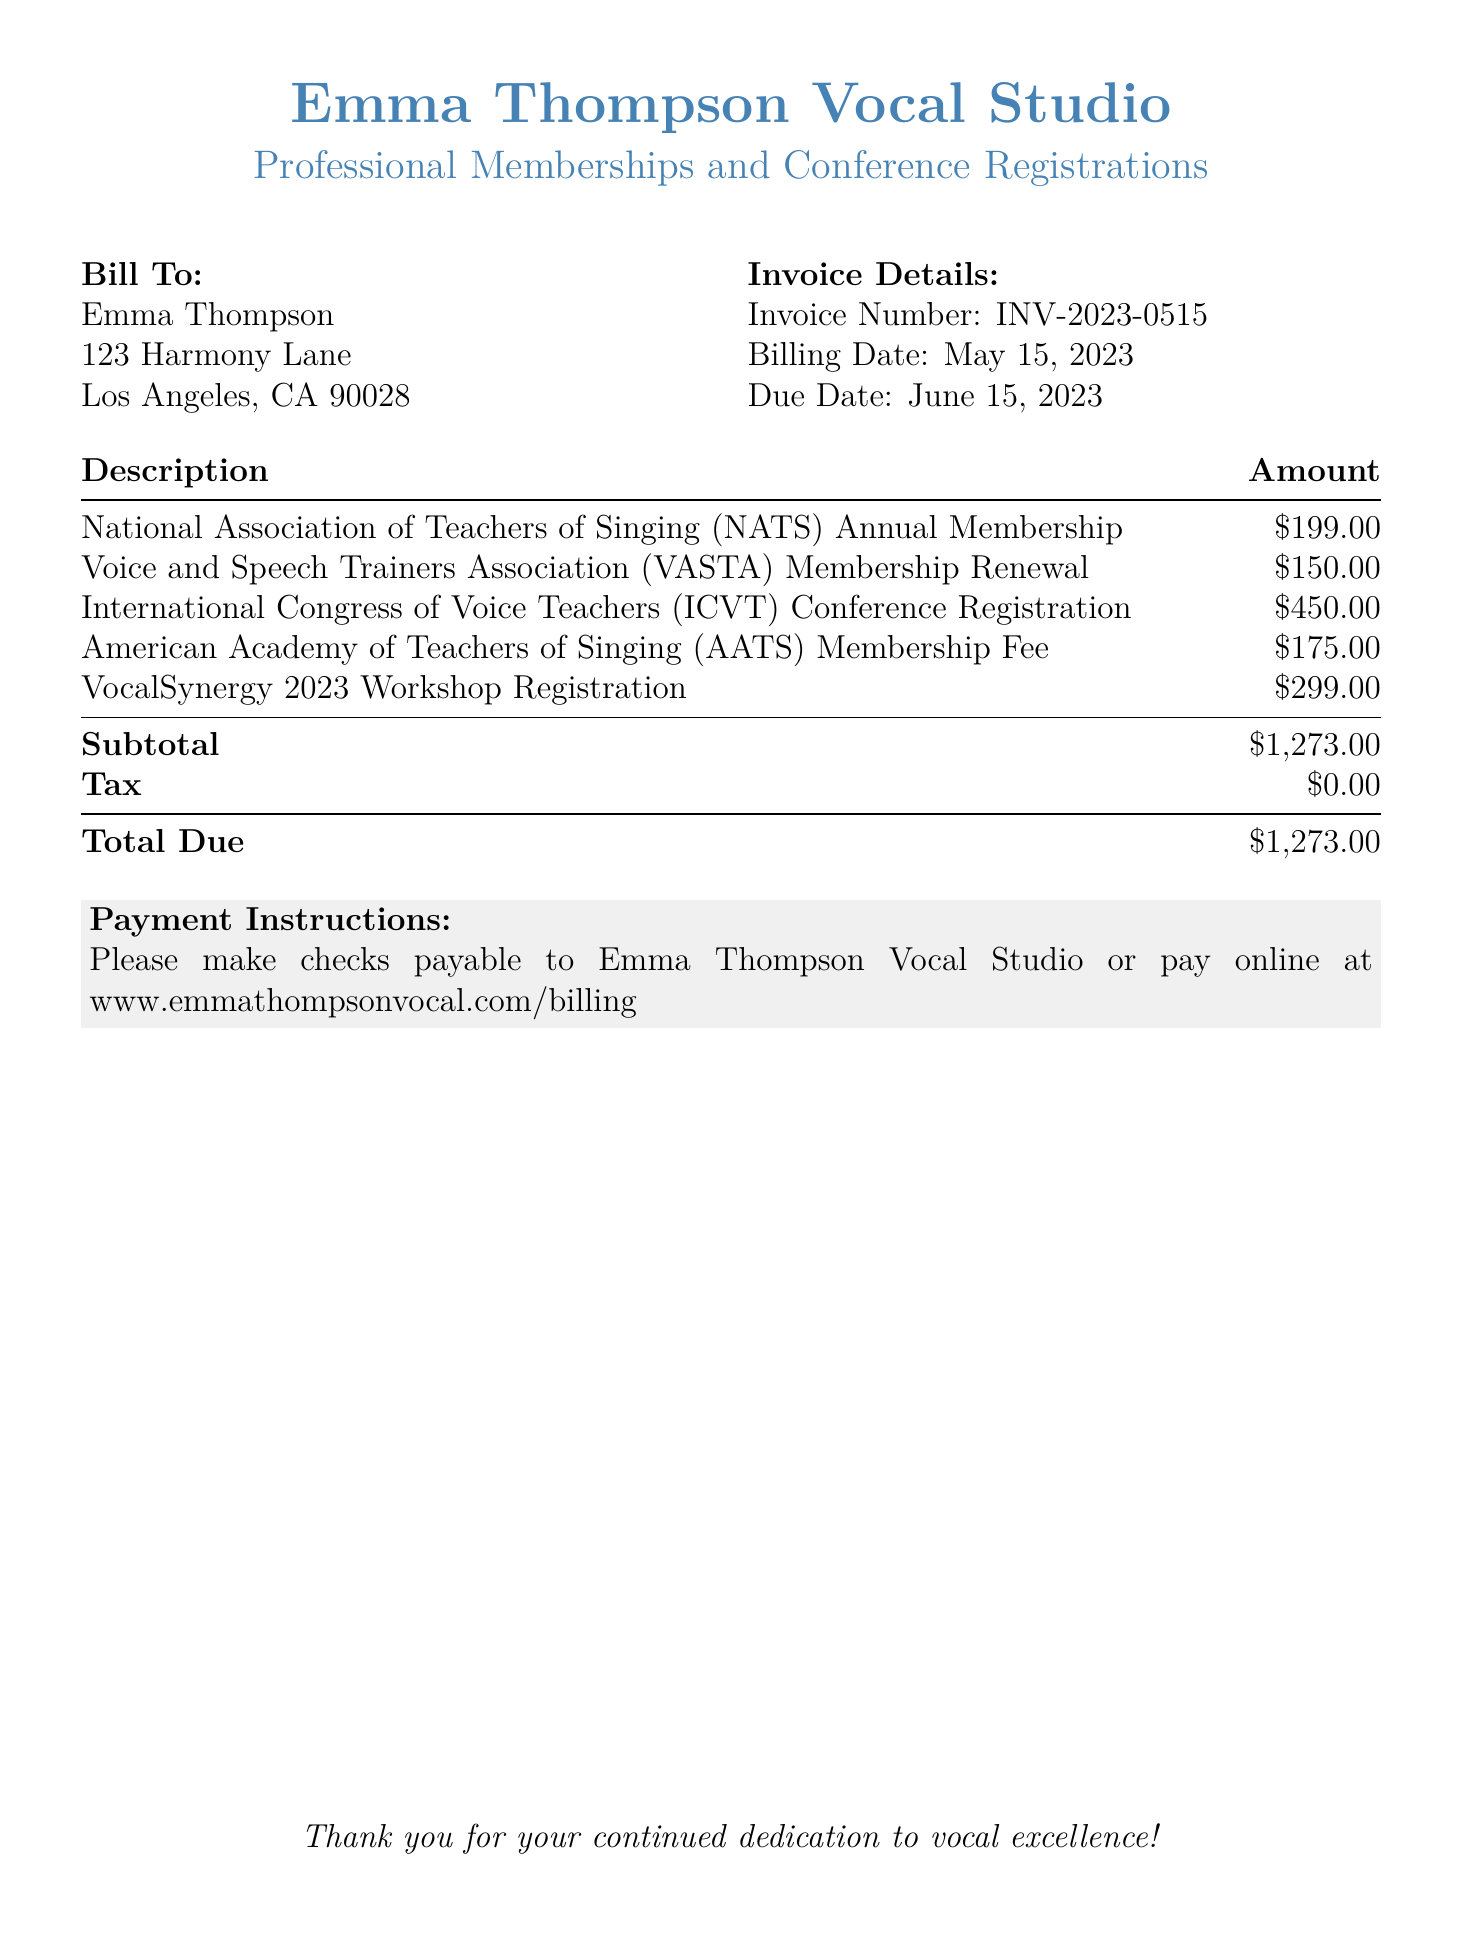What is the bill total? The total due is mentioned at the bottom of the document, which is the sum of all charges including memberships and registrations.
Answer: $1,273.00 Who is the bill addressed to? The bill is addressed to the person named at the top of the bill under "Bill To."
Answer: Emma Thompson What is the due date for payment? The due date is listed in the invoice details section of the document.
Answer: June 15, 2023 How much is the membership fee for the National Association of Teachers of Singing? The amount is explicitly stated in the description of the bill under the membership section.
Answer: $199.00 What is the invoice number? The invoice number is a unique identifier located in the invoice details section.
Answer: INV-2023-0515 What was the payment method suggested in the document? The document mentions how to make payments and suggests two methods for settling the bill.
Answer: Checks or online payment What is the subtotal before tax? The subtotal is specified before tax in the breakdown of amounts in the document.
Answer: $1,273.00 What is the fee for the Voice and Speech Trainers Association membership renewal? This fee is detailed in the description of expenses listed in the document.
Answer: $150.00 What workshop registration is listed in the bill? The document lists a specific workshop registration under the description of charges.
Answer: VocalSynergy 2023 Workshop Registration 